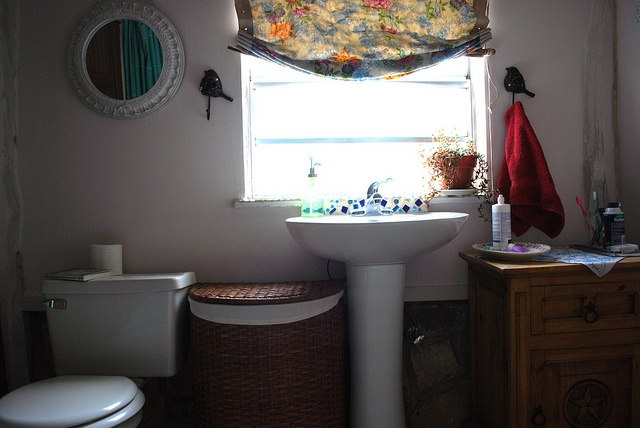Describe the objects in this image and their specific colors. I can see toilet in black, gray, and darkgray tones, sink in black, gray, white, and darkgray tones, potted plant in black, white, maroon, and gray tones, bottle in black, gray, and lightgray tones, and toothbrush in black and purple tones in this image. 